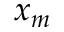Convert formula to latex. <formula><loc_0><loc_0><loc_500><loc_500>x _ { m }</formula> 